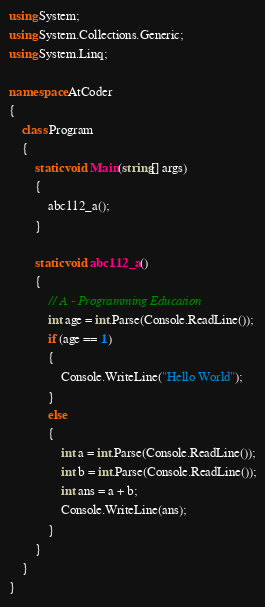Convert code to text. <code><loc_0><loc_0><loc_500><loc_500><_C#_>using System;
using System.Collections.Generic;
using System.Linq;

namespace AtCoder
{
    class Program
    {
        static void Main(string[] args)
        {
            abc112_a();
        }

        static void abc112_a()
        {
            // A - Programming Education
            int age = int.Parse(Console.ReadLine());
            if (age == 1)
            {
                Console.WriteLine("Hello World");
            }
            else
            {
                int a = int.Parse(Console.ReadLine());
                int b = int.Parse(Console.ReadLine());
                int ans = a + b;
                Console.WriteLine(ans);
            }
        }
    }
}</code> 